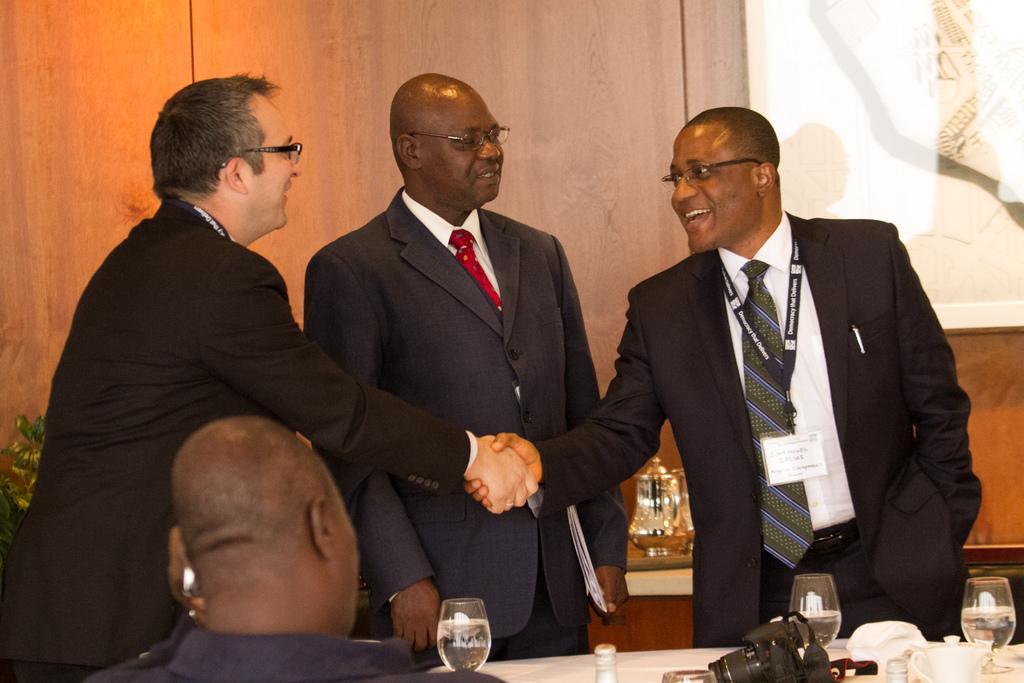Could you give a brief overview of what you see in this image? In this image, we can see persons wearing clothes. There are two persons shaking hands. There is a person in the middle of the image holding a file with his hand. There is a table at the bottom of the image contains camera, glasses and cups. There is a painting in the top right of the image. 